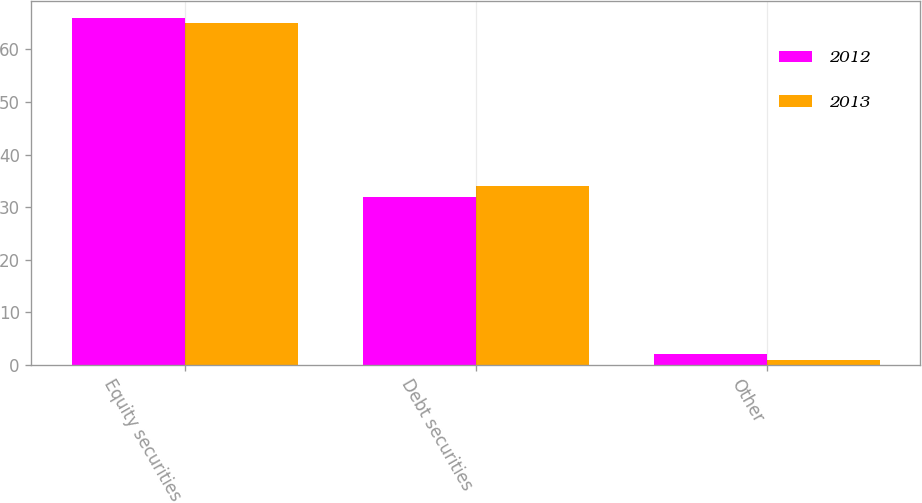<chart> <loc_0><loc_0><loc_500><loc_500><stacked_bar_chart><ecel><fcel>Equity securities<fcel>Debt securities<fcel>Other<nl><fcel>2012<fcel>66<fcel>32<fcel>2<nl><fcel>2013<fcel>65<fcel>34<fcel>1<nl></chart> 